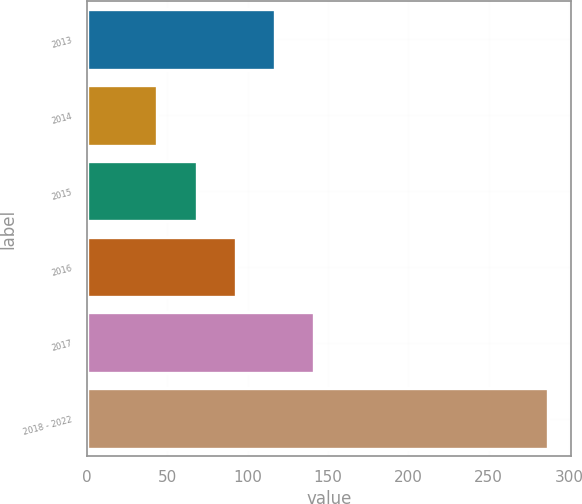Convert chart. <chart><loc_0><loc_0><loc_500><loc_500><bar_chart><fcel>2013<fcel>2014<fcel>2015<fcel>2016<fcel>2017<fcel>2018 - 2022<nl><fcel>116.9<fcel>44<fcel>68.3<fcel>92.6<fcel>141.2<fcel>287<nl></chart> 